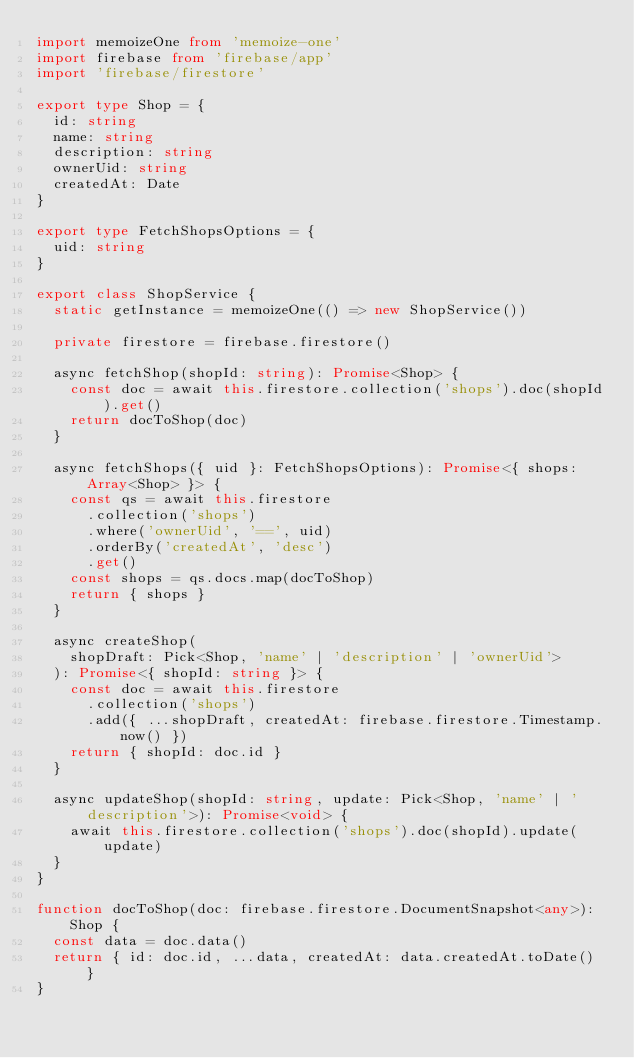Convert code to text. <code><loc_0><loc_0><loc_500><loc_500><_TypeScript_>import memoizeOne from 'memoize-one'
import firebase from 'firebase/app'
import 'firebase/firestore'

export type Shop = {
  id: string
  name: string
  description: string
  ownerUid: string
  createdAt: Date
}

export type FetchShopsOptions = {
  uid: string
}

export class ShopService {
  static getInstance = memoizeOne(() => new ShopService())

  private firestore = firebase.firestore()

  async fetchShop(shopId: string): Promise<Shop> {
    const doc = await this.firestore.collection('shops').doc(shopId).get()
    return docToShop(doc)
  }

  async fetchShops({ uid }: FetchShopsOptions): Promise<{ shops: Array<Shop> }> {
    const qs = await this.firestore
      .collection('shops')
      .where('ownerUid', '==', uid)
      .orderBy('createdAt', 'desc')
      .get()
    const shops = qs.docs.map(docToShop)
    return { shops }
  }

  async createShop(
    shopDraft: Pick<Shop, 'name' | 'description' | 'ownerUid'>
  ): Promise<{ shopId: string }> {
    const doc = await this.firestore
      .collection('shops')
      .add({ ...shopDraft, createdAt: firebase.firestore.Timestamp.now() })
    return { shopId: doc.id }
  }

  async updateShop(shopId: string, update: Pick<Shop, 'name' | 'description'>): Promise<void> {
    await this.firestore.collection('shops').doc(shopId).update(update)
  }
}

function docToShop(doc: firebase.firestore.DocumentSnapshot<any>): Shop {
  const data = doc.data()
  return { id: doc.id, ...data, createdAt: data.createdAt.toDate() }
}
</code> 